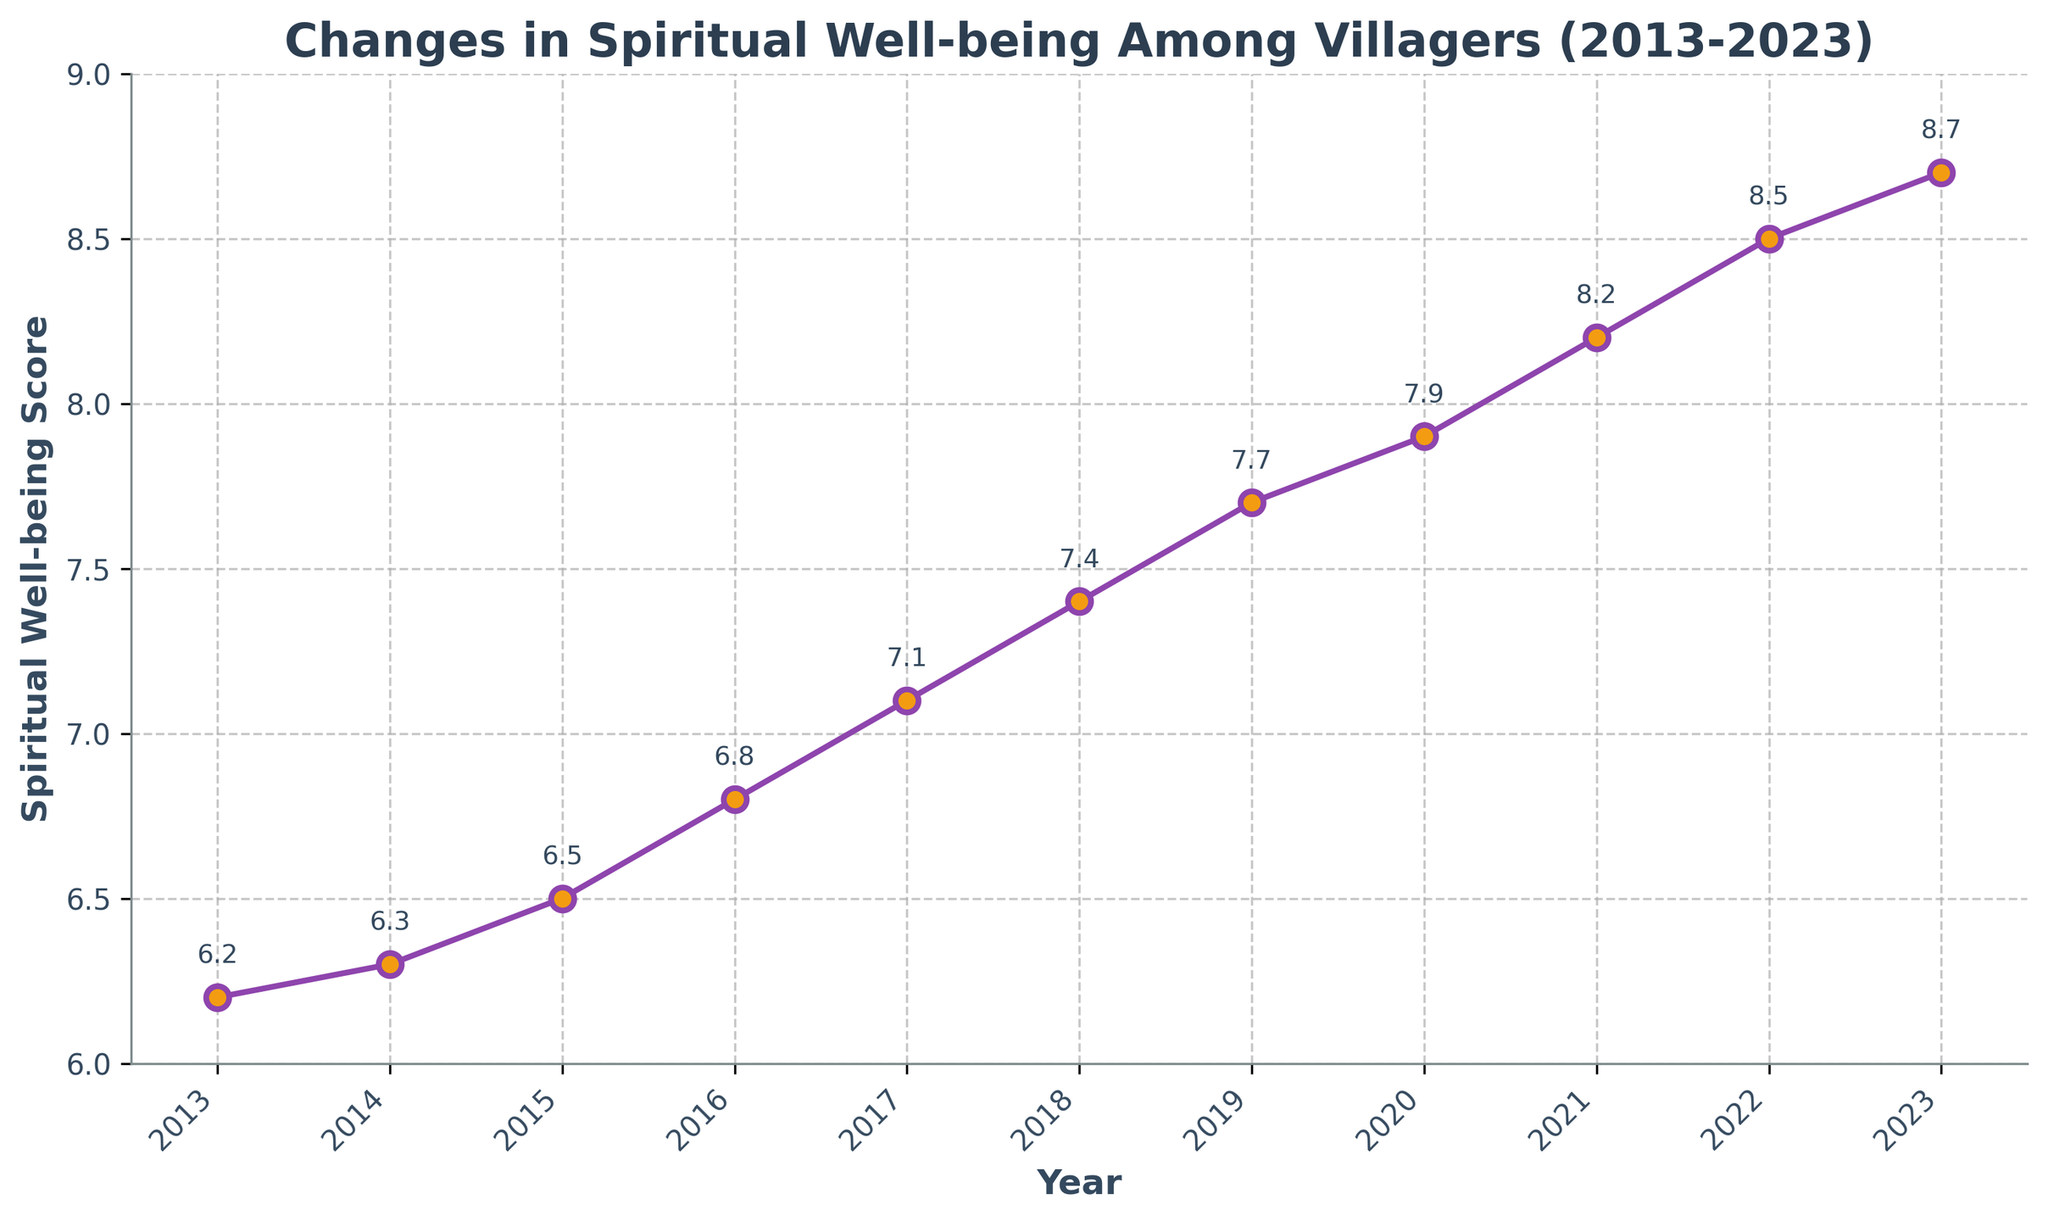What's the trend in the spiritual well-being scores from 2013 to 2023? The trend is determined by visually analyzing the pattern in the plotted line. From 2013 to 2023, the line steadily increases, indicating an upward trend in the spiritual well-being scores over the decade.
Answer: Upward trend In which year did the spiritual well-being score first reach above 7.5? To find when the score first exceeded 7.5, we examine the plotted points. The score surpasses 7.5 in 2019.
Answer: 2019 What is the difference in the spiritual well-being score between 2013 and 2023? To find the difference, we subtract the score in 2013 from that in 2023 (8.7 - 6.2).
Answer: 2.5 Between which two consecutive years was the largest increase in spiritual well-being score observed? By visually inspecting the gaps between points year-by-year, the largest increase appears between 2021 and 2022, where the score jumps from 8.2 to 8.5.
Answer: 2021-2022 What is the average spiritual well-being score over the decade? Sum all the yearly scores and divide by the number of years (sum = 6.2 + 6.3 + 6.5 + 6.8 + 7.1 + 7.4 + 7.7 + 7.9 + 8.2 + 8.5 + 8.7) / 11 = 7.29 (rounded off).
Answer: 7.29 Which year has the highest spiritual well-being score and what is the score? The year with the highest score is identified by locating the highest point on the plot, which is in 2023 with a score of 8.7.
Answer: 2023, 8.7 Compare the spiritual well-being scores of 2015 and 2020. Which year had a higher score and by how much? Comparing the scores for 2015 and 2020 (6.5 and 7.9 respectively), 2020 is higher. The difference is calculated as 7.9 - 6.5 = 1.4.
Answer: 2020, 1.4 What was the annual growth rate in spiritual well-being score from 2018 to 2021? Calculate the annual growth as [(8.2 - 7.4) / (2021 - 2018) = 0.8 / 3 ≈ 0.27].
Answer: 0.27 per year How many years did it take for the score to move from 7 to above 8? The score crossed 7 in 2017 and reached above 8 in 2021, hence taking 4 years (2021 - 2017).
Answer: 4 years 